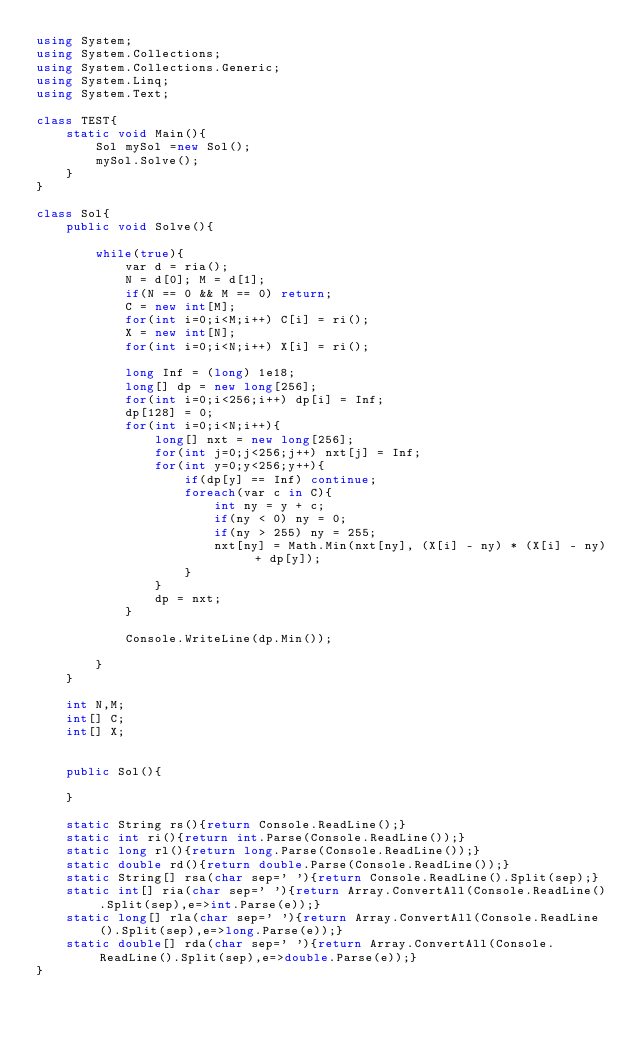Convert code to text. <code><loc_0><loc_0><loc_500><loc_500><_C#_>using System;
using System.Collections;
using System.Collections.Generic;
using System.Linq;
using System.Text;

class TEST{
	static void Main(){
		Sol mySol =new Sol();
		mySol.Solve();
	}
}

class Sol{
	public void Solve(){
		
		while(true){
			var d = ria();
			N = d[0]; M = d[1];
			if(N == 0 && M == 0) return;
			C = new int[M];
			for(int i=0;i<M;i++) C[i] = ri();
			X = new int[N];
			for(int i=0;i<N;i++) X[i] = ri();
			
			long Inf = (long) 1e18;
			long[] dp = new long[256];
			for(int i=0;i<256;i++) dp[i] = Inf;
			dp[128] = 0;
			for(int i=0;i<N;i++){
				long[] nxt = new long[256];
				for(int j=0;j<256;j++) nxt[j] = Inf;
				for(int y=0;y<256;y++){
					if(dp[y] == Inf) continue;
					foreach(var c in C){
						int ny = y + c;
						if(ny < 0) ny = 0;
						if(ny > 255) ny = 255;
						nxt[ny] = Math.Min(nxt[ny], (X[i] - ny) * (X[i] - ny) + dp[y]);
					}
				}
				dp = nxt;
			}
			
			Console.WriteLine(dp.Min());
			
		}
	}
	
	int N,M;
	int[] C;
	int[] X;
	
	
	public Sol(){
		
	}

	static String rs(){return Console.ReadLine();}
	static int ri(){return int.Parse(Console.ReadLine());}
	static long rl(){return long.Parse(Console.ReadLine());}
	static double rd(){return double.Parse(Console.ReadLine());}
	static String[] rsa(char sep=' '){return Console.ReadLine().Split(sep);}
	static int[] ria(char sep=' '){return Array.ConvertAll(Console.ReadLine().Split(sep),e=>int.Parse(e));}
	static long[] rla(char sep=' '){return Array.ConvertAll(Console.ReadLine().Split(sep),e=>long.Parse(e));}
	static double[] rda(char sep=' '){return Array.ConvertAll(Console.ReadLine().Split(sep),e=>double.Parse(e));}
}</code> 